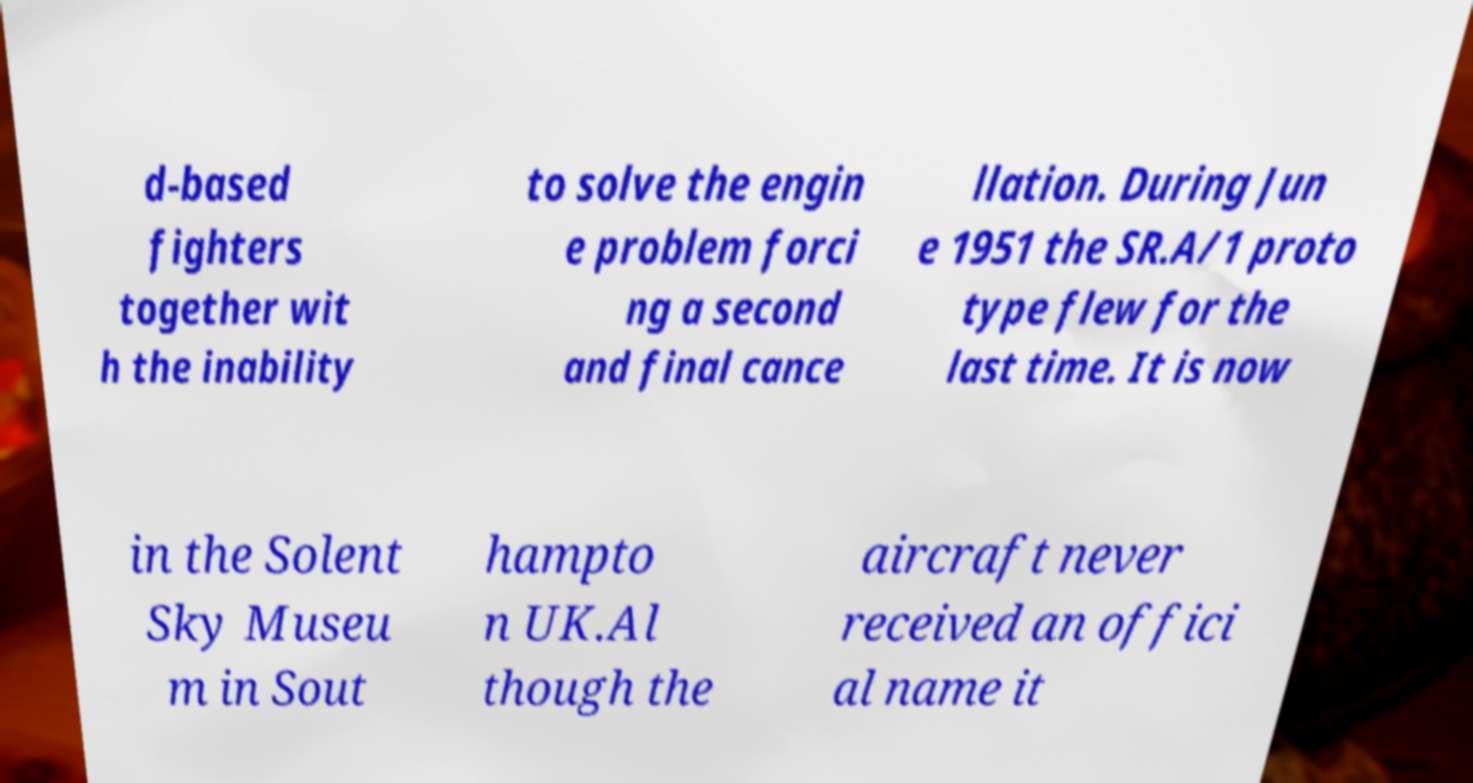There's text embedded in this image that I need extracted. Can you transcribe it verbatim? d-based fighters together wit h the inability to solve the engin e problem forci ng a second and final cance llation. During Jun e 1951 the SR.A/1 proto type flew for the last time. It is now in the Solent Sky Museu m in Sout hampto n UK.Al though the aircraft never received an offici al name it 